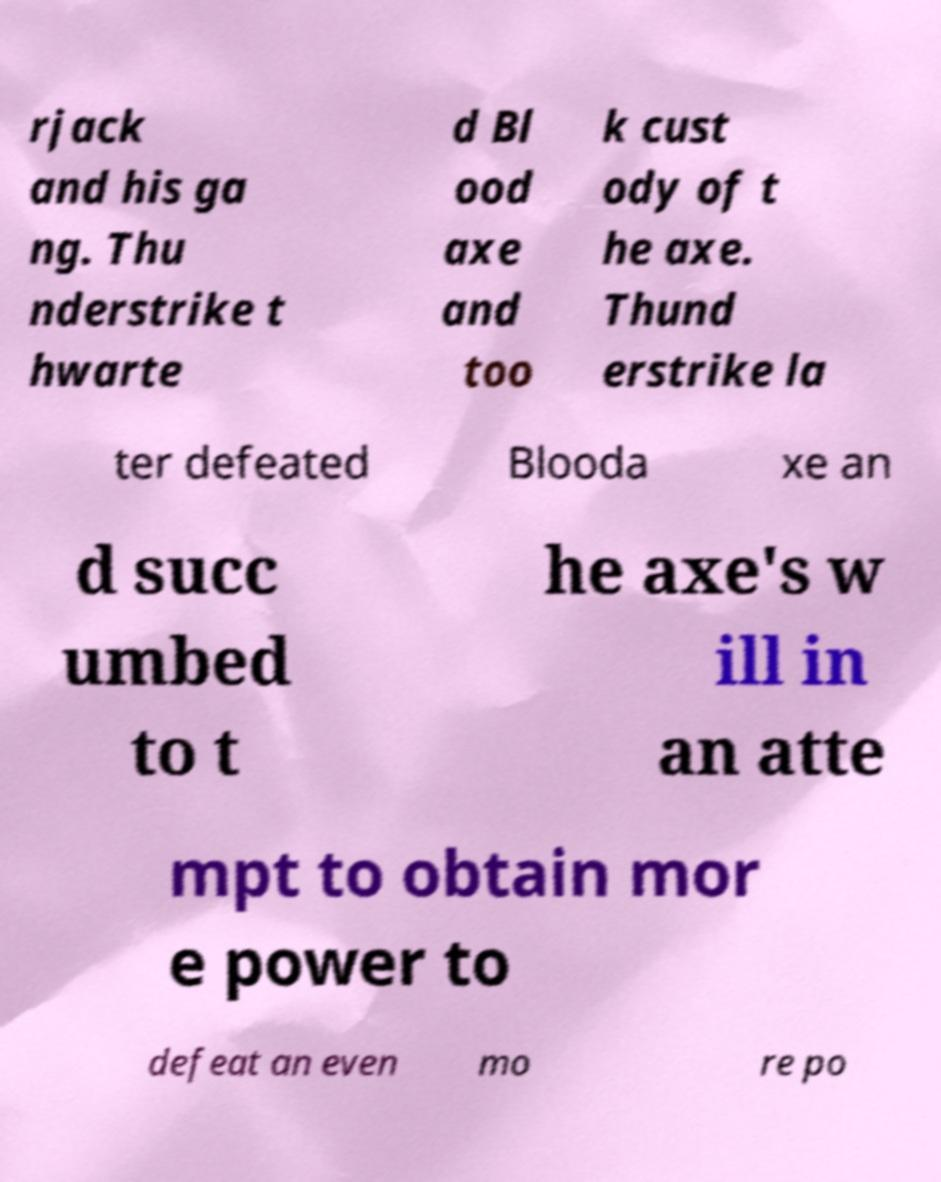Could you assist in decoding the text presented in this image and type it out clearly? rjack and his ga ng. Thu nderstrike t hwarte d Bl ood axe and too k cust ody of t he axe. Thund erstrike la ter defeated Blooda xe an d succ umbed to t he axe's w ill in an atte mpt to obtain mor e power to defeat an even mo re po 